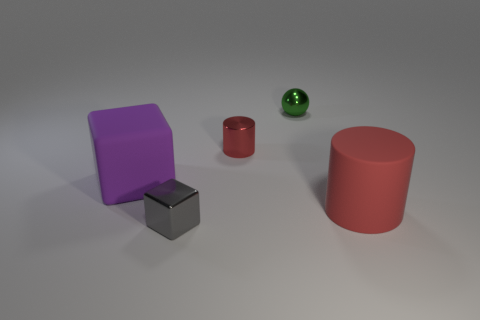Add 5 matte objects. How many objects exist? 10 Subtract all purple blocks. How many blocks are left? 1 Subtract 1 cylinders. How many cylinders are left? 1 Subtract all purple blocks. How many purple cylinders are left? 0 Add 2 tiny purple metal things. How many tiny purple metal things exist? 2 Subtract 0 purple cylinders. How many objects are left? 5 Subtract all cylinders. How many objects are left? 3 Subtract all brown cubes. Subtract all brown cylinders. How many cubes are left? 2 Subtract all big matte cubes. Subtract all cylinders. How many objects are left? 2 Add 5 red rubber cylinders. How many red rubber cylinders are left? 6 